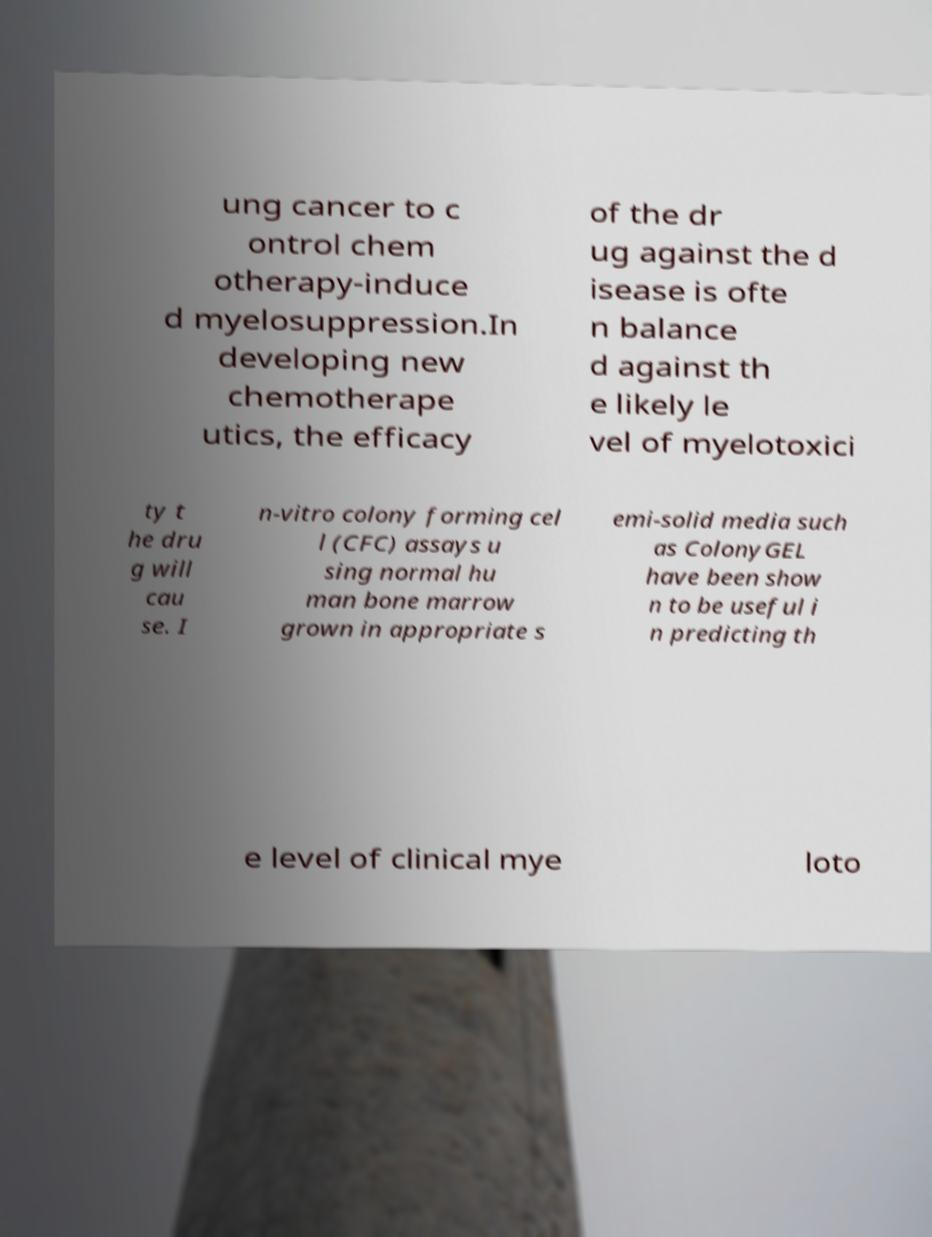Please read and relay the text visible in this image. What does it say? ung cancer to c ontrol chem otherapy-induce d myelosuppression.In developing new chemotherape utics, the efficacy of the dr ug against the d isease is ofte n balance d against th e likely le vel of myelotoxici ty t he dru g will cau se. I n-vitro colony forming cel l (CFC) assays u sing normal hu man bone marrow grown in appropriate s emi-solid media such as ColonyGEL have been show n to be useful i n predicting th e level of clinical mye loto 